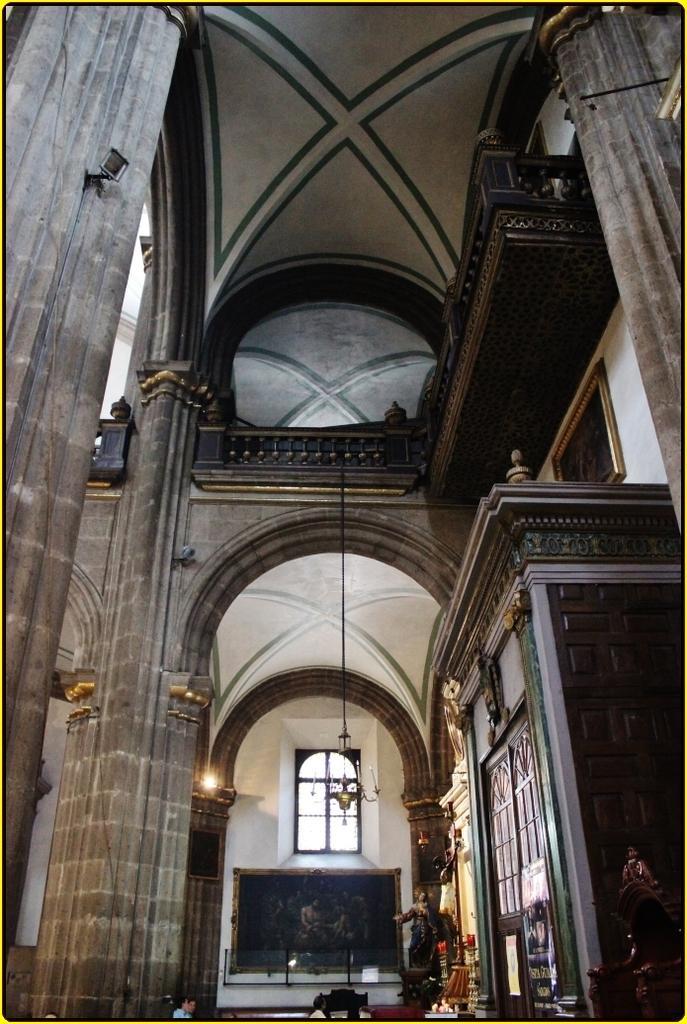Describe this image in one or two sentences. The picture is taken inside a big room where at the right corner there is one wooden room and in the middle there is one black board on the wall and one chandelier is hanging from the roof and coming to the roof there is small balcony present in the room. 